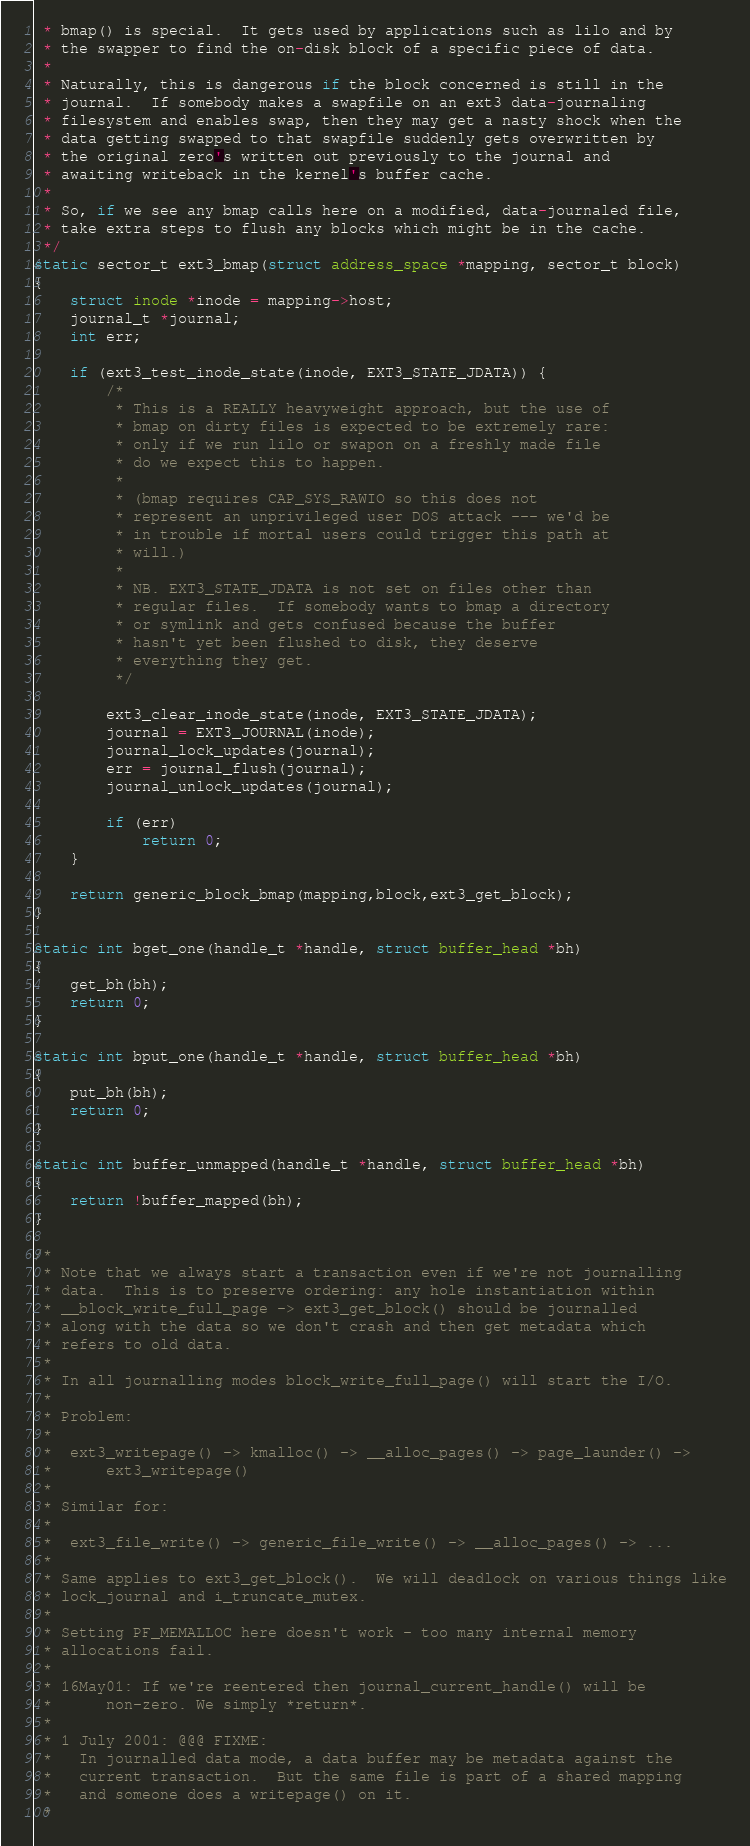<code> <loc_0><loc_0><loc_500><loc_500><_C_> * bmap() is special.  It gets used by applications such as lilo and by
 * the swapper to find the on-disk block of a specific piece of data.
 *
 * Naturally, this is dangerous if the block concerned is still in the
 * journal.  If somebody makes a swapfile on an ext3 data-journaling
 * filesystem and enables swap, then they may get a nasty shock when the
 * data getting swapped to that swapfile suddenly gets overwritten by
 * the original zero's written out previously to the journal and
 * awaiting writeback in the kernel's buffer cache.
 *
 * So, if we see any bmap calls here on a modified, data-journaled file,
 * take extra steps to flush any blocks which might be in the cache.
 */
static sector_t ext3_bmap(struct address_space *mapping, sector_t block)
{
	struct inode *inode = mapping->host;
	journal_t *journal;
	int err;

	if (ext3_test_inode_state(inode, EXT3_STATE_JDATA)) {
		/*
		 * This is a REALLY heavyweight approach, but the use of
		 * bmap on dirty files is expected to be extremely rare:
		 * only if we run lilo or swapon on a freshly made file
		 * do we expect this to happen.
		 *
		 * (bmap requires CAP_SYS_RAWIO so this does not
		 * represent an unprivileged user DOS attack --- we'd be
		 * in trouble if mortal users could trigger this path at
		 * will.)
		 *
		 * NB. EXT3_STATE_JDATA is not set on files other than
		 * regular files.  If somebody wants to bmap a directory
		 * or symlink and gets confused because the buffer
		 * hasn't yet been flushed to disk, they deserve
		 * everything they get.
		 */

		ext3_clear_inode_state(inode, EXT3_STATE_JDATA);
		journal = EXT3_JOURNAL(inode);
		journal_lock_updates(journal);
		err = journal_flush(journal);
		journal_unlock_updates(journal);

		if (err)
			return 0;
	}

	return generic_block_bmap(mapping,block,ext3_get_block);
}

static int bget_one(handle_t *handle, struct buffer_head *bh)
{
	get_bh(bh);
	return 0;
}

static int bput_one(handle_t *handle, struct buffer_head *bh)
{
	put_bh(bh);
	return 0;
}

static int buffer_unmapped(handle_t *handle, struct buffer_head *bh)
{
	return !buffer_mapped(bh);
}

/*
 * Note that we always start a transaction even if we're not journalling
 * data.  This is to preserve ordering: any hole instantiation within
 * __block_write_full_page -> ext3_get_block() should be journalled
 * along with the data so we don't crash and then get metadata which
 * refers to old data.
 *
 * In all journalling modes block_write_full_page() will start the I/O.
 *
 * Problem:
 *
 *	ext3_writepage() -> kmalloc() -> __alloc_pages() -> page_launder() ->
 *		ext3_writepage()
 *
 * Similar for:
 *
 *	ext3_file_write() -> generic_file_write() -> __alloc_pages() -> ...
 *
 * Same applies to ext3_get_block().  We will deadlock on various things like
 * lock_journal and i_truncate_mutex.
 *
 * Setting PF_MEMALLOC here doesn't work - too many internal memory
 * allocations fail.
 *
 * 16May01: If we're reentered then journal_current_handle() will be
 *	    non-zero. We simply *return*.
 *
 * 1 July 2001: @@@ FIXME:
 *   In journalled data mode, a data buffer may be metadata against the
 *   current transaction.  But the same file is part of a shared mapping
 *   and someone does a writepage() on it.
 *</code> 